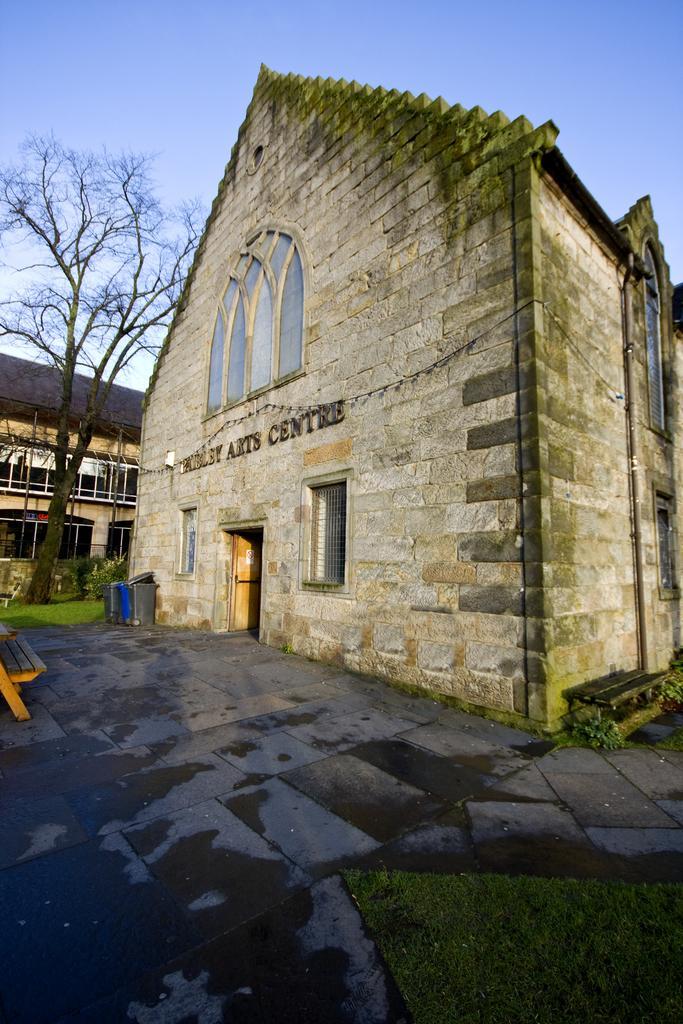Could you give a brief overview of what you see in this image? In this picture we can see two buildings, on the left side there is a bench, we can see grass, plants, a tree and a dustbin in the middle, we can see windows of these buildings, there is the sky at the top of the picture. 